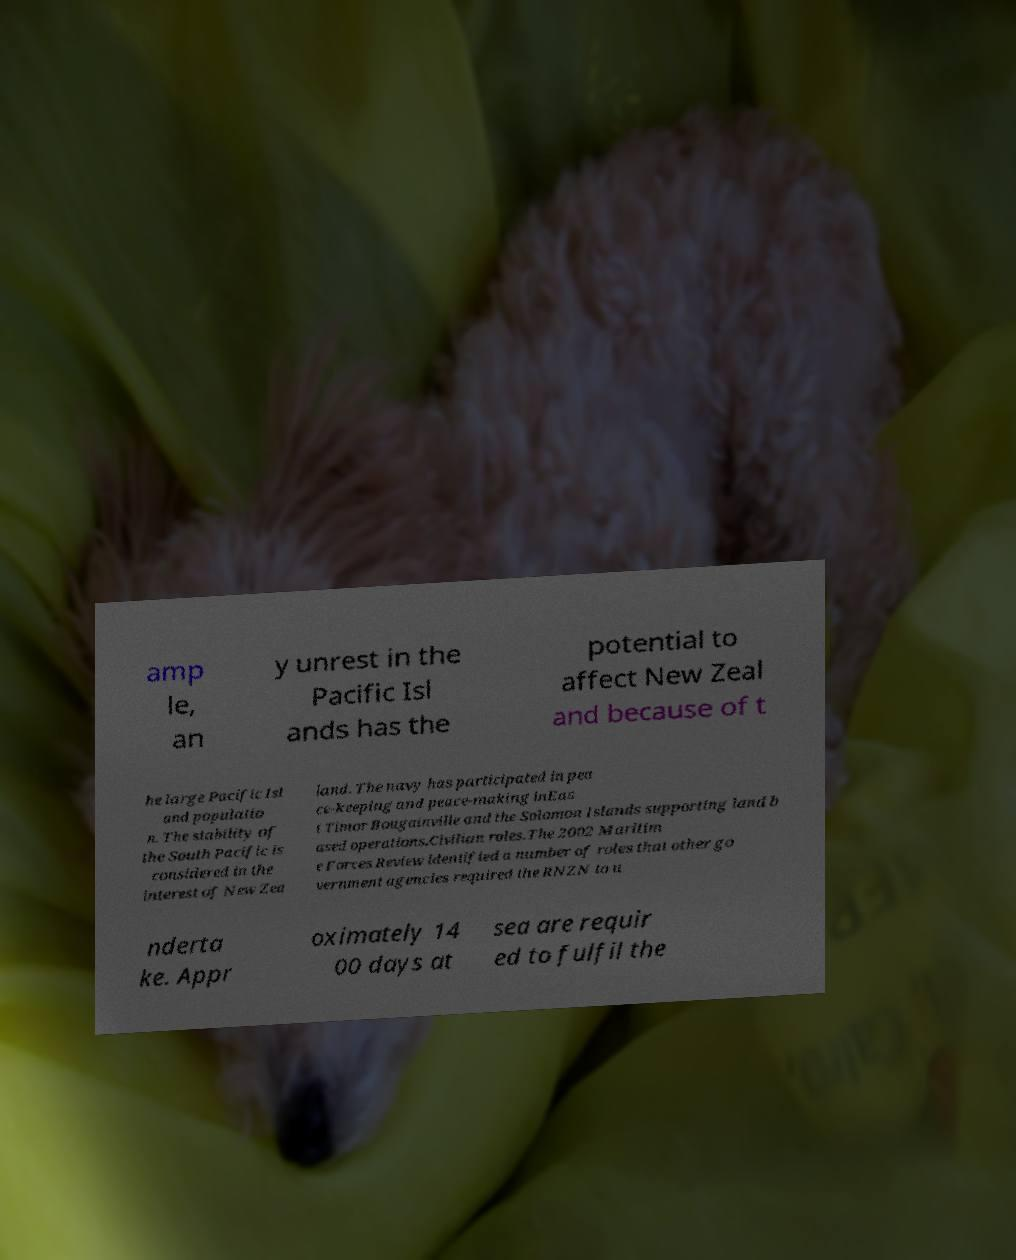What messages or text are displayed in this image? I need them in a readable, typed format. amp le, an y unrest in the Pacific Isl ands has the potential to affect New Zeal and because of t he large Pacific Isl and populatio n. The stability of the South Pacific is considered in the interest of New Zea land. The navy has participated in pea ce-keeping and peace-making inEas t Timor Bougainville and the Solomon Islands supporting land b ased operations.Civilian roles.The 2002 Maritim e Forces Review identified a number of roles that other go vernment agencies required the RNZN to u nderta ke. Appr oximately 14 00 days at sea are requir ed to fulfil the 